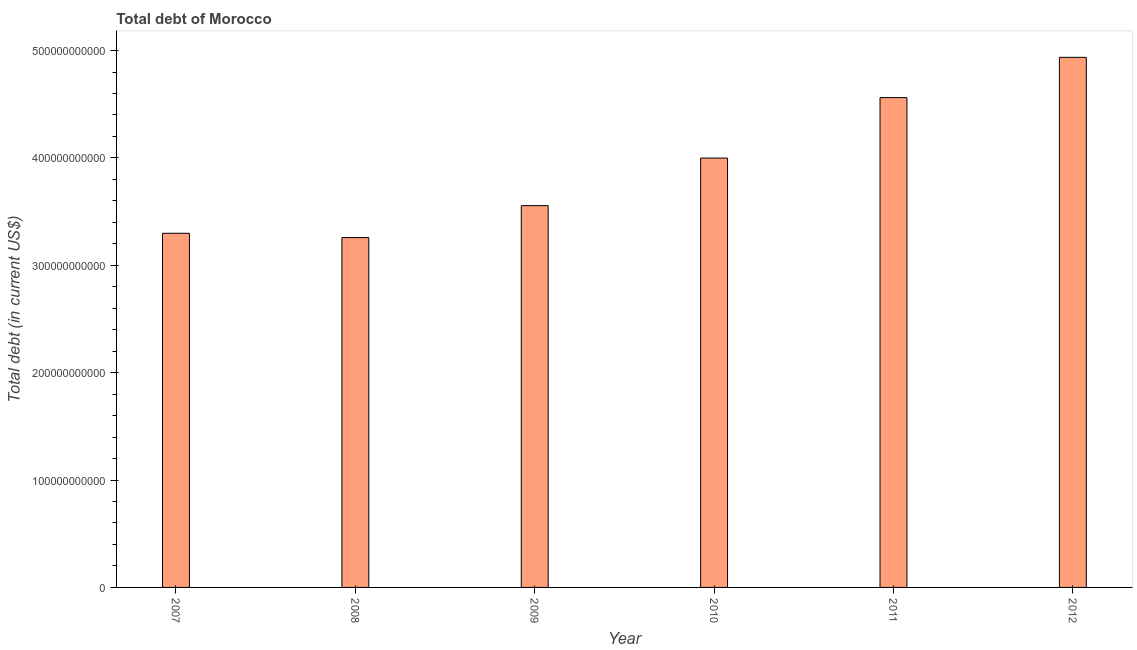What is the title of the graph?
Provide a short and direct response. Total debt of Morocco. What is the label or title of the Y-axis?
Make the answer very short. Total debt (in current US$). What is the total debt in 2007?
Your answer should be compact. 3.30e+11. Across all years, what is the maximum total debt?
Give a very brief answer. 4.94e+11. Across all years, what is the minimum total debt?
Provide a succinct answer. 3.26e+11. What is the sum of the total debt?
Make the answer very short. 2.36e+12. What is the difference between the total debt in 2008 and 2010?
Offer a very short reply. -7.41e+1. What is the average total debt per year?
Your response must be concise. 3.93e+11. What is the median total debt?
Give a very brief answer. 3.78e+11. In how many years, is the total debt greater than 340000000000 US$?
Keep it short and to the point. 4. What is the ratio of the total debt in 2009 to that in 2011?
Keep it short and to the point. 0.78. Is the total debt in 2008 less than that in 2009?
Keep it short and to the point. Yes. What is the difference between the highest and the second highest total debt?
Your answer should be very brief. 3.75e+1. Is the sum of the total debt in 2008 and 2012 greater than the maximum total debt across all years?
Provide a short and direct response. Yes. What is the difference between the highest and the lowest total debt?
Offer a very short reply. 1.68e+11. Are all the bars in the graph horizontal?
Provide a short and direct response. No. What is the difference between two consecutive major ticks on the Y-axis?
Your response must be concise. 1.00e+11. What is the Total debt (in current US$) in 2007?
Your answer should be very brief. 3.30e+11. What is the Total debt (in current US$) of 2008?
Keep it short and to the point. 3.26e+11. What is the Total debt (in current US$) of 2009?
Keep it short and to the point. 3.56e+11. What is the Total debt (in current US$) of 2010?
Keep it short and to the point. 4.00e+11. What is the Total debt (in current US$) in 2011?
Provide a succinct answer. 4.56e+11. What is the Total debt (in current US$) of 2012?
Your answer should be very brief. 4.94e+11. What is the difference between the Total debt (in current US$) in 2007 and 2008?
Give a very brief answer. 4.02e+09. What is the difference between the Total debt (in current US$) in 2007 and 2009?
Your answer should be very brief. -2.57e+1. What is the difference between the Total debt (in current US$) in 2007 and 2010?
Give a very brief answer. -7.00e+1. What is the difference between the Total debt (in current US$) in 2007 and 2011?
Provide a succinct answer. -1.26e+11. What is the difference between the Total debt (in current US$) in 2007 and 2012?
Keep it short and to the point. -1.64e+11. What is the difference between the Total debt (in current US$) in 2008 and 2009?
Your response must be concise. -2.98e+1. What is the difference between the Total debt (in current US$) in 2008 and 2010?
Offer a terse response. -7.41e+1. What is the difference between the Total debt (in current US$) in 2008 and 2011?
Give a very brief answer. -1.30e+11. What is the difference between the Total debt (in current US$) in 2008 and 2012?
Ensure brevity in your answer.  -1.68e+11. What is the difference between the Total debt (in current US$) in 2009 and 2010?
Offer a terse response. -4.43e+1. What is the difference between the Total debt (in current US$) in 2009 and 2011?
Offer a terse response. -1.01e+11. What is the difference between the Total debt (in current US$) in 2009 and 2012?
Offer a terse response. -1.38e+11. What is the difference between the Total debt (in current US$) in 2010 and 2011?
Offer a terse response. -5.63e+1. What is the difference between the Total debt (in current US$) in 2010 and 2012?
Keep it short and to the point. -9.38e+1. What is the difference between the Total debt (in current US$) in 2011 and 2012?
Make the answer very short. -3.75e+1. What is the ratio of the Total debt (in current US$) in 2007 to that in 2008?
Give a very brief answer. 1.01. What is the ratio of the Total debt (in current US$) in 2007 to that in 2009?
Give a very brief answer. 0.93. What is the ratio of the Total debt (in current US$) in 2007 to that in 2010?
Offer a terse response. 0.82. What is the ratio of the Total debt (in current US$) in 2007 to that in 2011?
Provide a short and direct response. 0.72. What is the ratio of the Total debt (in current US$) in 2007 to that in 2012?
Your response must be concise. 0.67. What is the ratio of the Total debt (in current US$) in 2008 to that in 2009?
Make the answer very short. 0.92. What is the ratio of the Total debt (in current US$) in 2008 to that in 2010?
Provide a succinct answer. 0.81. What is the ratio of the Total debt (in current US$) in 2008 to that in 2011?
Your answer should be very brief. 0.71. What is the ratio of the Total debt (in current US$) in 2008 to that in 2012?
Give a very brief answer. 0.66. What is the ratio of the Total debt (in current US$) in 2009 to that in 2010?
Ensure brevity in your answer.  0.89. What is the ratio of the Total debt (in current US$) in 2009 to that in 2011?
Make the answer very short. 0.78. What is the ratio of the Total debt (in current US$) in 2009 to that in 2012?
Keep it short and to the point. 0.72. What is the ratio of the Total debt (in current US$) in 2010 to that in 2011?
Give a very brief answer. 0.88. What is the ratio of the Total debt (in current US$) in 2010 to that in 2012?
Give a very brief answer. 0.81. What is the ratio of the Total debt (in current US$) in 2011 to that in 2012?
Provide a succinct answer. 0.92. 